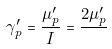Convert formula to latex. <formula><loc_0><loc_0><loc_500><loc_500>\gamma _ { p } ^ { \prime } = \frac { \mu _ { p } ^ { \prime } } { I } = \frac { 2 \mu _ { p } ^ { \prime } } { }</formula> 